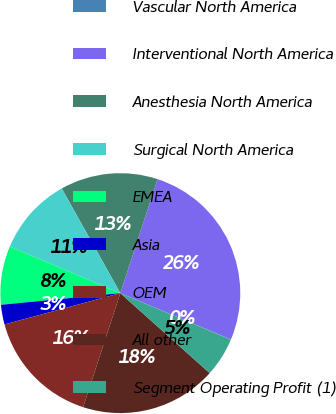Convert chart to OTSL. <chart><loc_0><loc_0><loc_500><loc_500><pie_chart><fcel>Vascular North America<fcel>Interventional North America<fcel>Anesthesia North America<fcel>Surgical North America<fcel>EMEA<fcel>Asia<fcel>OEM<fcel>All other<fcel>Segment Operating Profit (1)<nl><fcel>0.03%<fcel>26.28%<fcel>13.15%<fcel>10.53%<fcel>7.9%<fcel>2.65%<fcel>15.78%<fcel>18.4%<fcel>5.28%<nl></chart> 